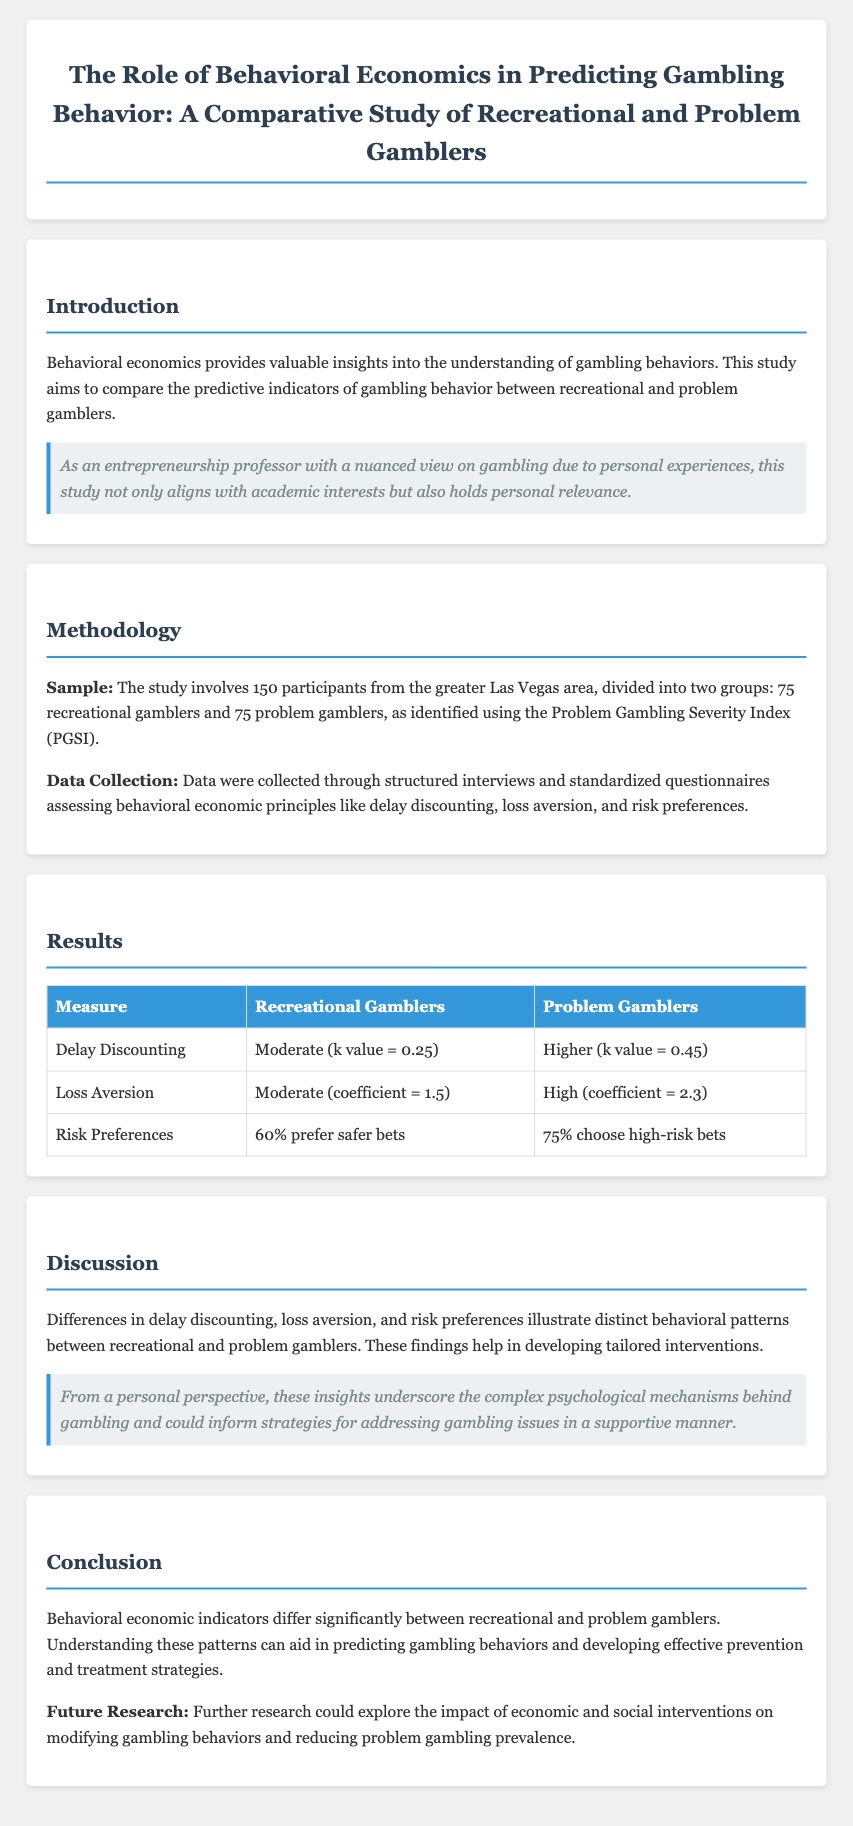What is the sample size of the study? The sample size consists of 150 participants, with equal distribution between the two groups.
Answer: 150 What are the two groups compared in the study? The study compares recreational gamblers and problem gamblers as identified using the PGSI.
Answer: Recreational gamblers and problem gamblers What is the k value for recreational gamblers? The document provides the k value for recreational gamblers as moderate, specifically noted.
Answer: 0.25 What does the coefficient for loss aversion indicate for problem gamblers? The study mentions that problem gamblers exhibit a high coefficient for loss aversion.
Answer: 2.3 What percentage of recreational gamblers prefer safer bets? The study indicates that a significant portion of recreational gamblers prefer safer bets, specified numerically.
Answer: 60% What behavioral pattern was observed in problem gamblers regarding risk preferences? The study shows that a majority of problem gamblers choose high-risk bets.
Answer: 75% What does the study suggest could help tailor interventions for gamblers? The document highlights that understanding differences in behavioral indicators aids in developing tailored interventions.
Answer: Behavioral patterns What is the potential area for future research suggested in the conclusion? The conclusion proposes that exploring economic and social interventions could inform further research.
Answer: Economic and social interventions What psychological mechanisms are emphasized in the discussion? The discussion underscores complex psychological mechanisms behind gambling behavior.
Answer: Psychological mechanisms 